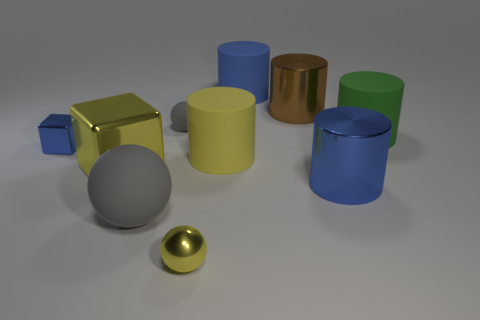Subtract all blue shiny cylinders. How many cylinders are left? 4 Subtract all yellow balls. How many balls are left? 2 Subtract 0 red balls. How many objects are left? 10 Subtract all cubes. How many objects are left? 8 Subtract 1 blocks. How many blocks are left? 1 Subtract all blue balls. Subtract all red cubes. How many balls are left? 3 Subtract all red blocks. How many yellow balls are left? 1 Subtract all yellow objects. Subtract all large gray rubber spheres. How many objects are left? 6 Add 5 yellow matte things. How many yellow matte things are left? 6 Add 6 cubes. How many cubes exist? 8 